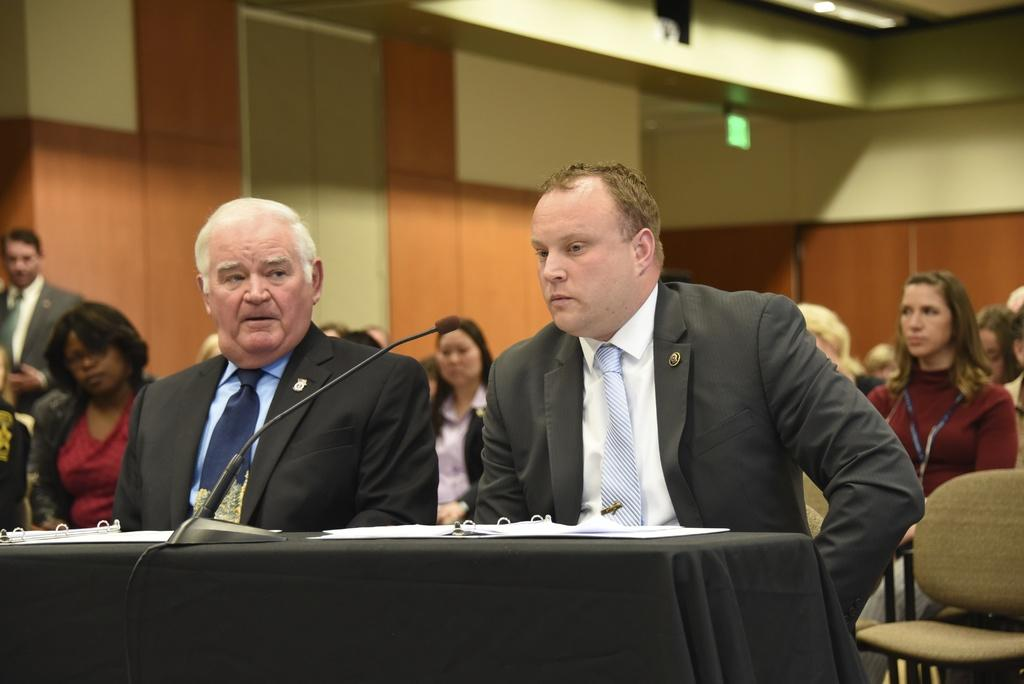Where was the image taken? The image was taken in a meeting hall. What are the people in the image doing? There are people sitting on chairs in the image. Can you describe the two people sitting in the front? The two people sitting in the front are wearing black suits. What is in front of the two people? There is a desk in front of the two people. What objects are on the desk? A microphone and papers are on the desk. What degree does the father of the person sitting in the front row have? There is no information about the father of any person in the image, nor is there any mention of degrees. 